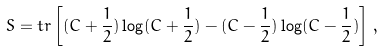Convert formula to latex. <formula><loc_0><loc_0><loc_500><loc_500>S = t r \left [ ( C + \frac { 1 } { 2 } ) \log ( C + \frac { 1 } { 2 } ) - ( C - \frac { 1 } { 2 } ) \log ( C - \frac { 1 } { 2 } ) \right ] \, , \\</formula> 